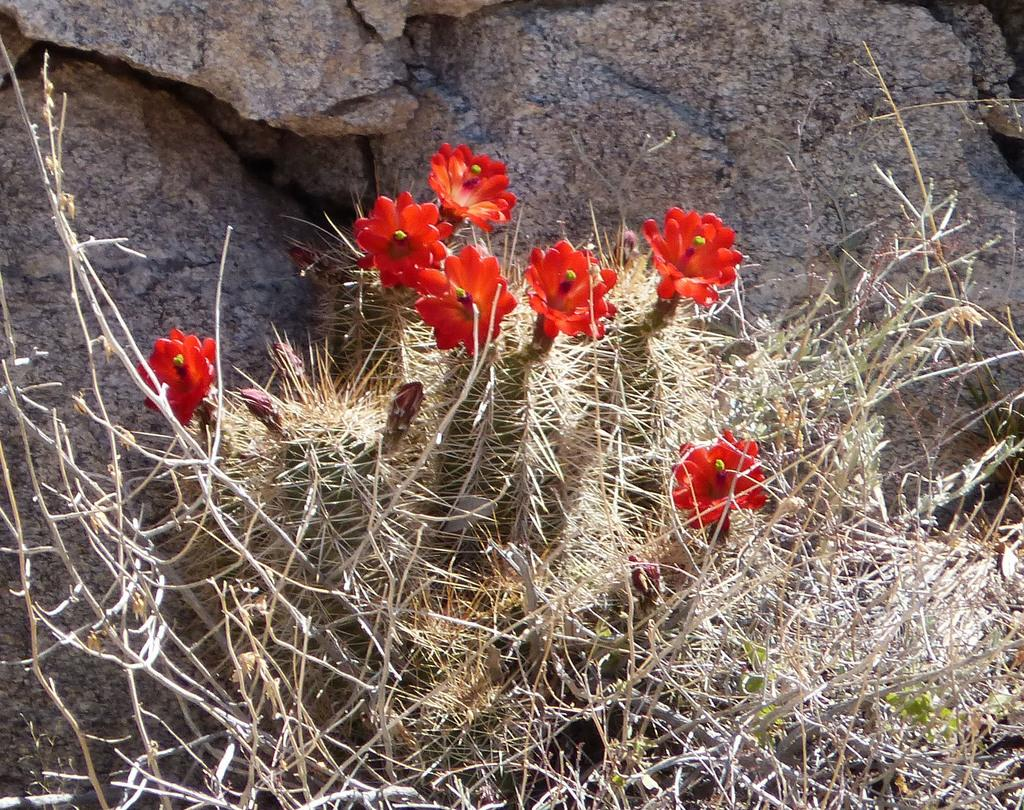What type of plant is visible in the image? There is a plant with flowers in the image. What can be seen in the background of the image? There are rocks in the background of the image. What type of produce is being harvested in the image? There is no produce being harvested in the image; it features a plant with flowers. What type of furniture is present in the image? There is no furniture present in the image; it features a plant with flowers and rocks in the background. 